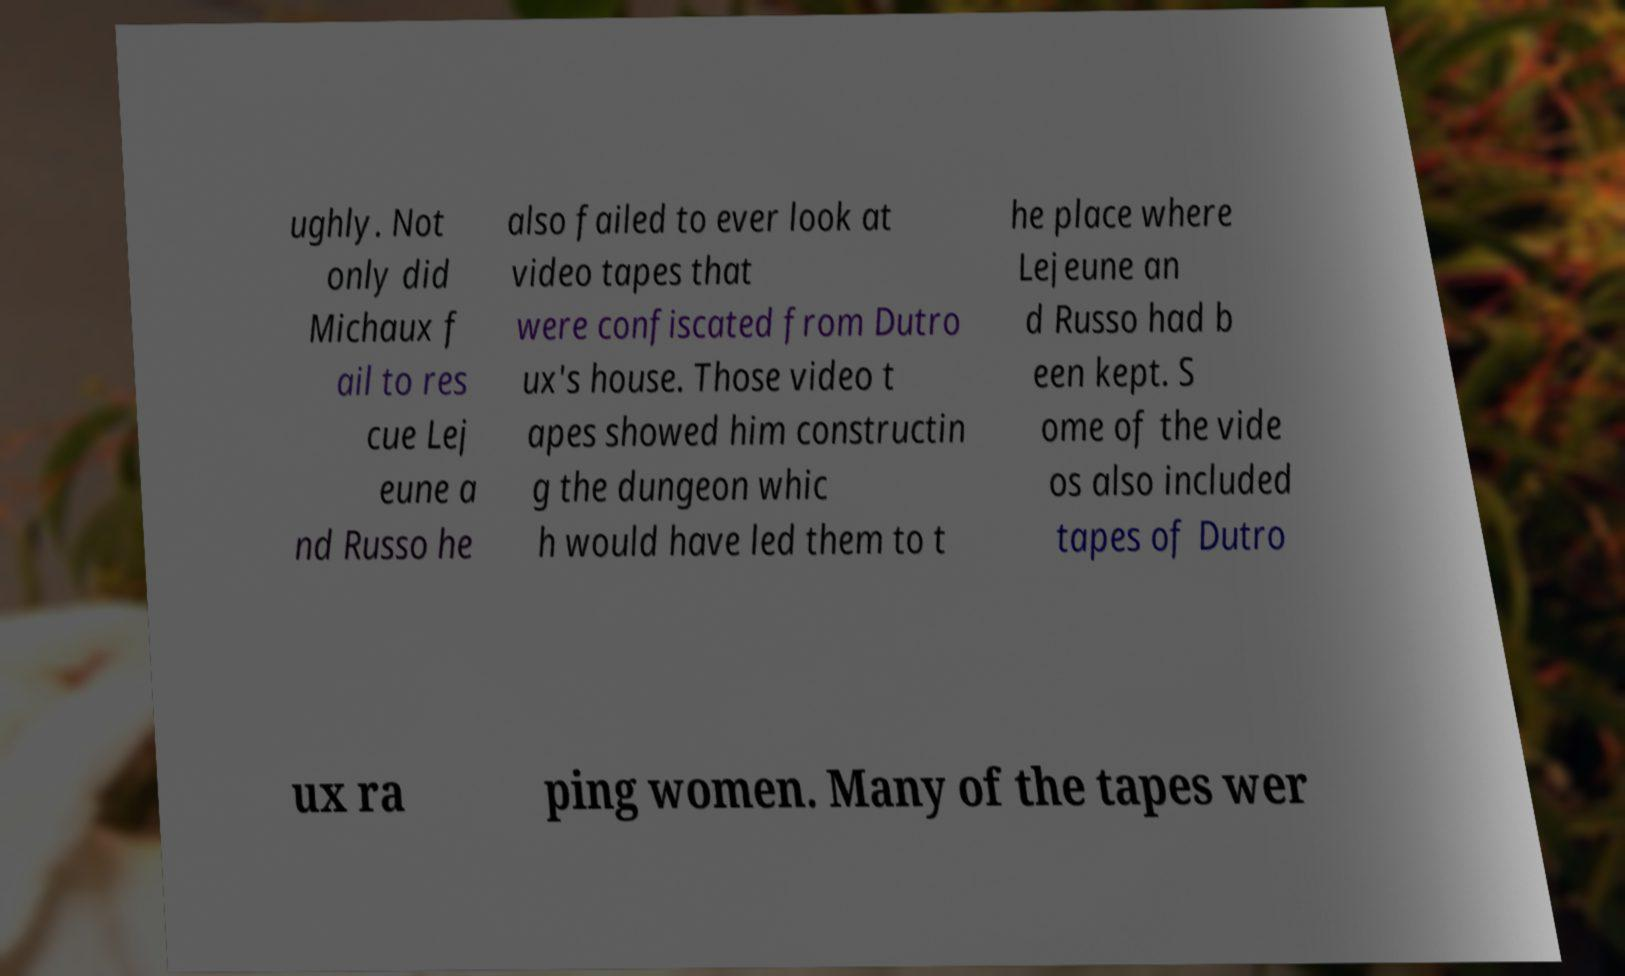I need the written content from this picture converted into text. Can you do that? ughly. Not only did Michaux f ail to res cue Lej eune a nd Russo he also failed to ever look at video tapes that were confiscated from Dutro ux's house. Those video t apes showed him constructin g the dungeon whic h would have led them to t he place where Lejeune an d Russo had b een kept. S ome of the vide os also included tapes of Dutro ux ra ping women. Many of the tapes wer 